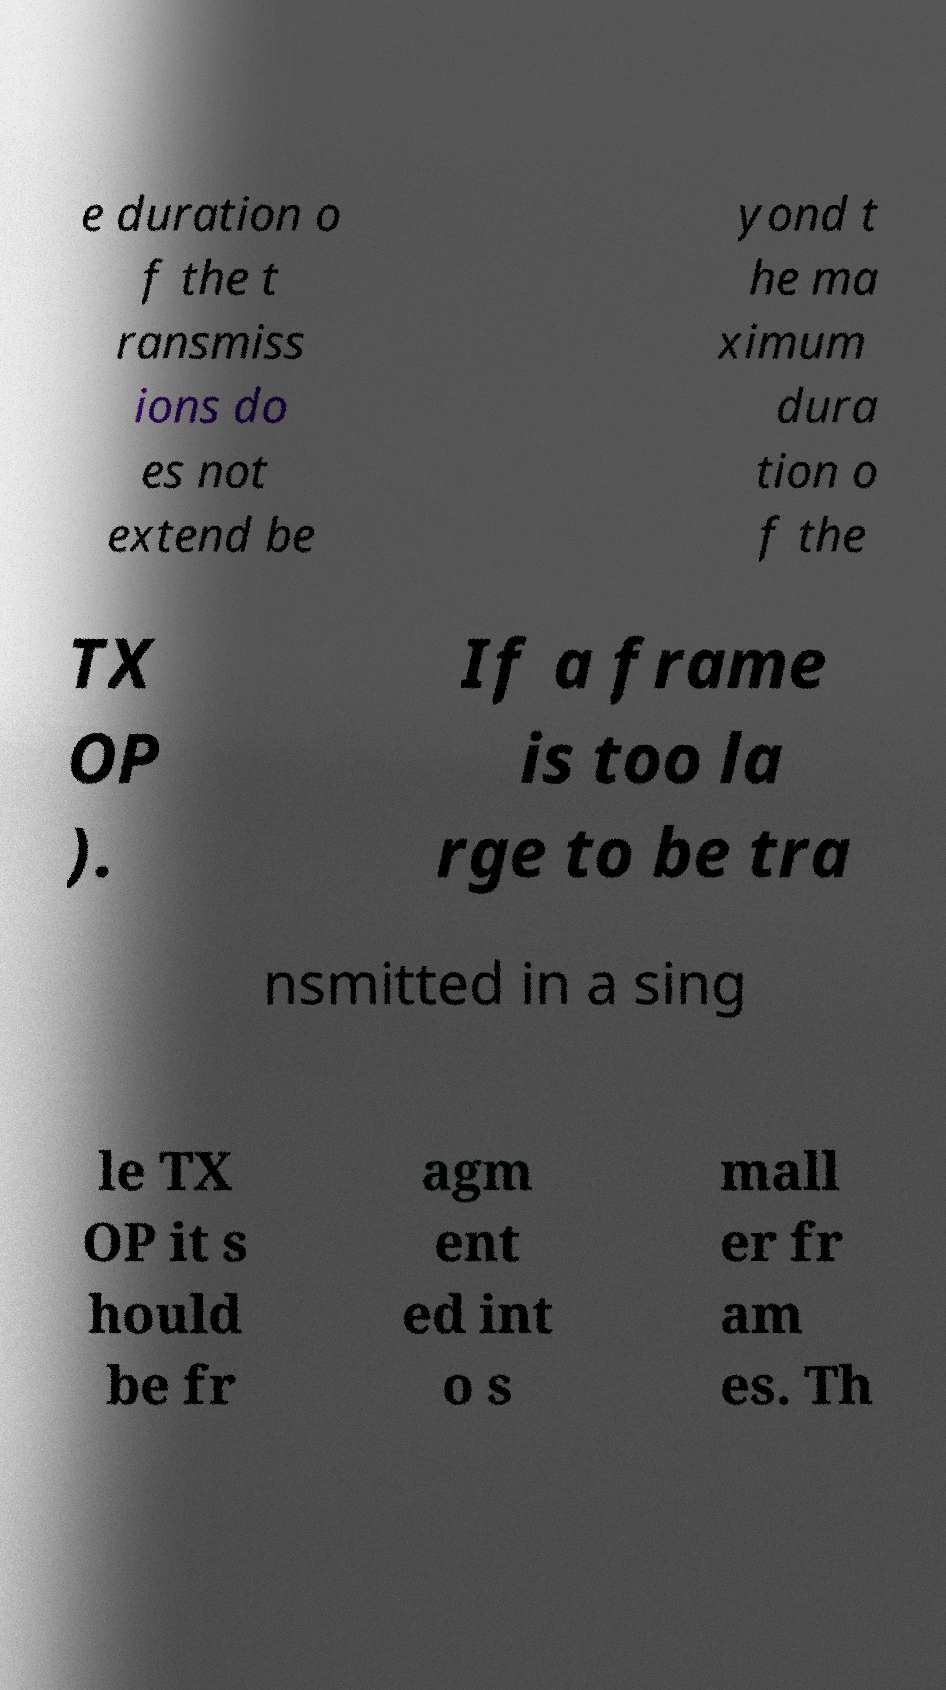Please identify and transcribe the text found in this image. e duration o f the t ransmiss ions do es not extend be yond t he ma ximum dura tion o f the TX OP ). If a frame is too la rge to be tra nsmitted in a sing le TX OP it s hould be fr agm ent ed int o s mall er fr am es. Th 